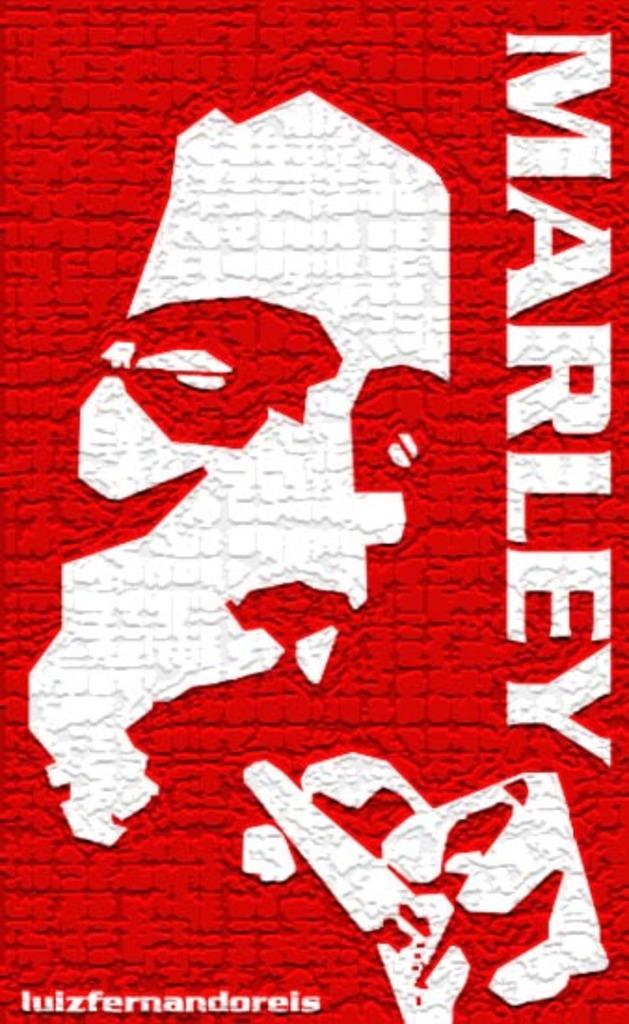<image>
Summarize the visual content of the image. A Bob Marley poster with an outline of Bob's face. 